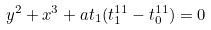Convert formula to latex. <formula><loc_0><loc_0><loc_500><loc_500>y ^ { 2 } + x ^ { 3 } + a t _ { 1 } ( t _ { 1 } ^ { 1 1 } - t _ { 0 } ^ { 1 1 } ) = 0</formula> 